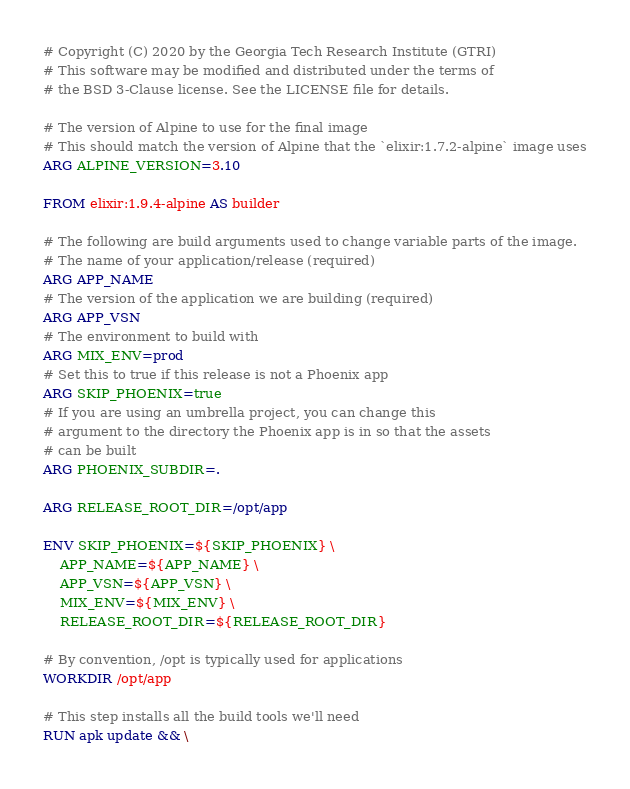<code> <loc_0><loc_0><loc_500><loc_500><_Dockerfile_># Copyright (C) 2020 by the Georgia Tech Research Institute (GTRI)
# This software may be modified and distributed under the terms of
# the BSD 3-Clause license. See the LICENSE file for details.

# The version of Alpine to use for the final image
# This should match the version of Alpine that the `elixir:1.7.2-alpine` image uses
ARG ALPINE_VERSION=3.10

FROM elixir:1.9.4-alpine AS builder

# The following are build arguments used to change variable parts of the image.
# The name of your application/release (required)
ARG APP_NAME
# The version of the application we are building (required)
ARG APP_VSN
# The environment to build with
ARG MIX_ENV=prod
# Set this to true if this release is not a Phoenix app
ARG SKIP_PHOENIX=true
# If you are using an umbrella project, you can change this
# argument to the directory the Phoenix app is in so that the assets
# can be built
ARG PHOENIX_SUBDIR=.

ARG RELEASE_ROOT_DIR=/opt/app

ENV SKIP_PHOENIX=${SKIP_PHOENIX} \
    APP_NAME=${APP_NAME} \
    APP_VSN=${APP_VSN} \
    MIX_ENV=${MIX_ENV} \
    RELEASE_ROOT_DIR=${RELEASE_ROOT_DIR}

# By convention, /opt is typically used for applications
WORKDIR /opt/app

# This step installs all the build tools we'll need
RUN apk update && \</code> 